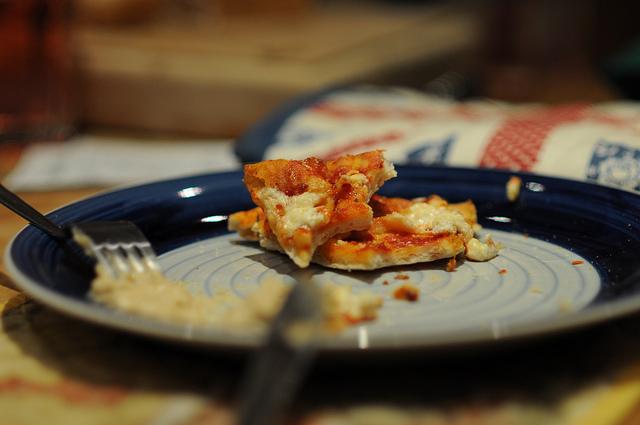Is this a deep dish pizza?
Write a very short answer. No. Are they having coffee?
Be succinct. No. What color is the plate?
Concise answer only. Blue. Has the majority of the pizza already been eaten?
Answer briefly. Yes. Are there any cookies?
Give a very brief answer. No. Was the pizza tasty?
Keep it brief. Yes. 